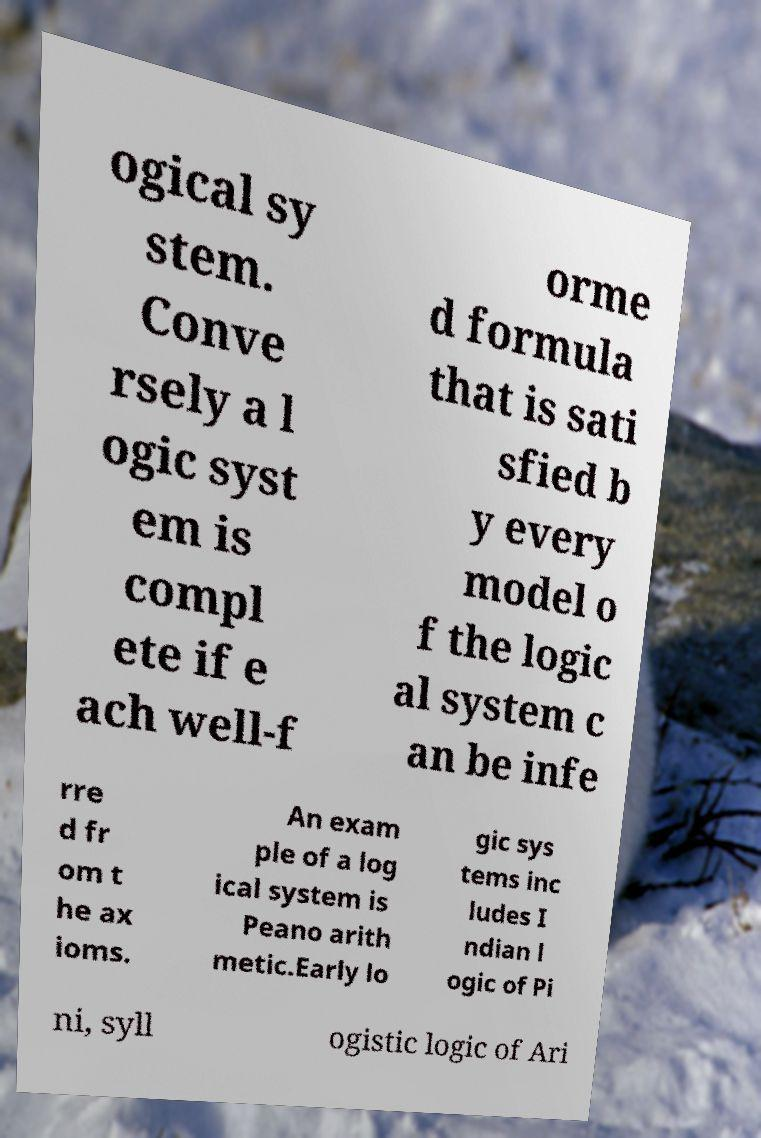Can you accurately transcribe the text from the provided image for me? ogical sy stem. Conve rsely a l ogic syst em is compl ete if e ach well-f orme d formula that is sati sfied b y every model o f the logic al system c an be infe rre d fr om t he ax ioms. An exam ple of a log ical system is Peano arith metic.Early lo gic sys tems inc ludes I ndian l ogic of Pi ni, syll ogistic logic of Ari 